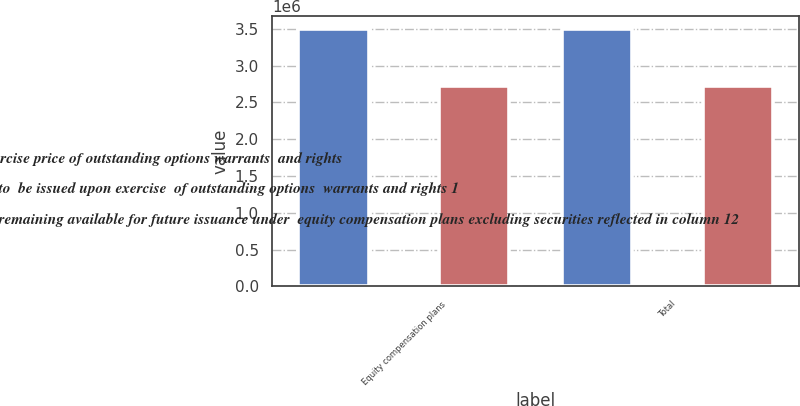Convert chart. <chart><loc_0><loc_0><loc_500><loc_500><stacked_bar_chart><ecel><fcel>Equity compensation plans<fcel>Total<nl><fcel>Weighted average exercise price of outstanding options warrants  and rights<fcel>3.50072e+06<fcel>3.50072e+06<nl><fcel>Number of securities to  be issued upon exercise  of outstanding options  warrants and rights 1<fcel>35.31<fcel>35.31<nl><fcel>Number of securities remaining available for future issuance under  equity compensation plans excluding securities reflected in column 12<fcel>2.72064e+06<fcel>2.72064e+06<nl></chart> 